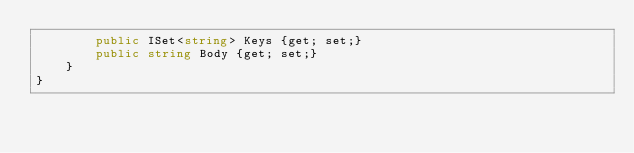<code> <loc_0><loc_0><loc_500><loc_500><_C#_>        public ISet<string> Keys {get; set;}
        public string Body {get; set;}
    }
}</code> 